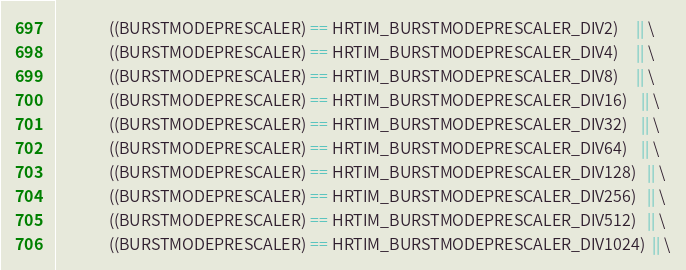Convert code to text. <code><loc_0><loc_0><loc_500><loc_500><_C_>               ((BURSTMODEPRESCALER) == HRTIM_BURSTMODEPRESCALER_DIV2)     || \
               ((BURSTMODEPRESCALER) == HRTIM_BURSTMODEPRESCALER_DIV4)     || \
               ((BURSTMODEPRESCALER) == HRTIM_BURSTMODEPRESCALER_DIV8)     || \
               ((BURSTMODEPRESCALER) == HRTIM_BURSTMODEPRESCALER_DIV16)    || \
               ((BURSTMODEPRESCALER) == HRTIM_BURSTMODEPRESCALER_DIV32)    || \
               ((BURSTMODEPRESCALER) == HRTIM_BURSTMODEPRESCALER_DIV64)    || \
               ((BURSTMODEPRESCALER) == HRTIM_BURSTMODEPRESCALER_DIV128)   || \
               ((BURSTMODEPRESCALER) == HRTIM_BURSTMODEPRESCALER_DIV256)   || \
               ((BURSTMODEPRESCALER) == HRTIM_BURSTMODEPRESCALER_DIV512)   || \
               ((BURSTMODEPRESCALER) == HRTIM_BURSTMODEPRESCALER_DIV1024)  || \</code> 